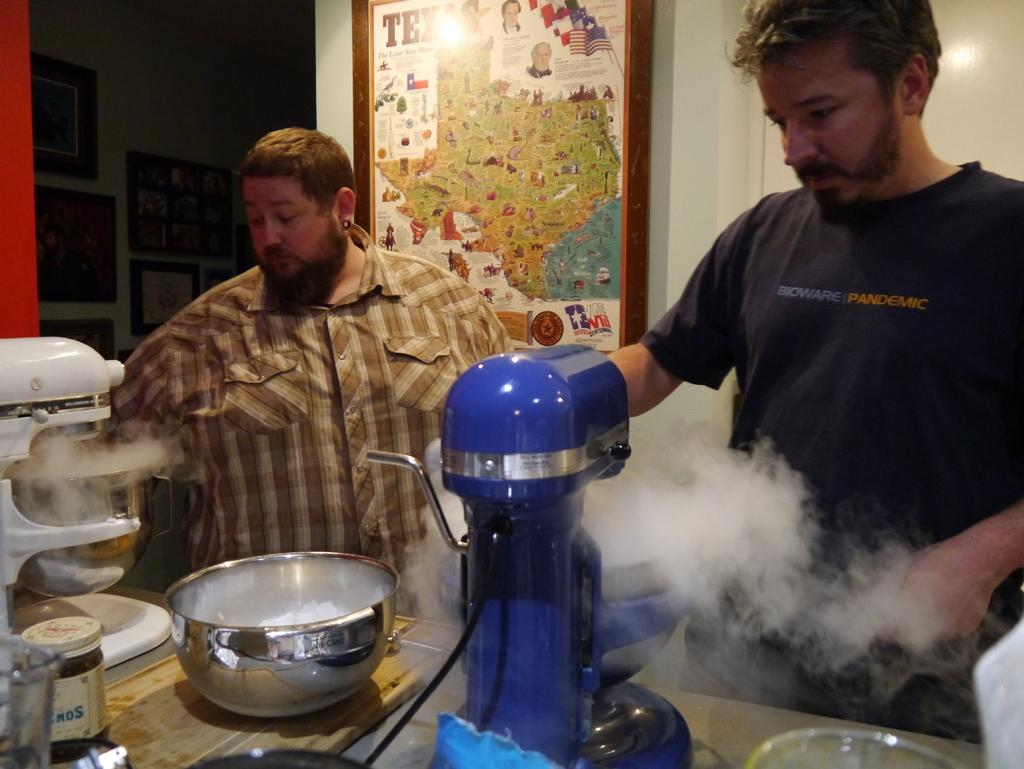<image>
Provide a brief description of the given image. a person wearing a shirt that says Bioware on it 